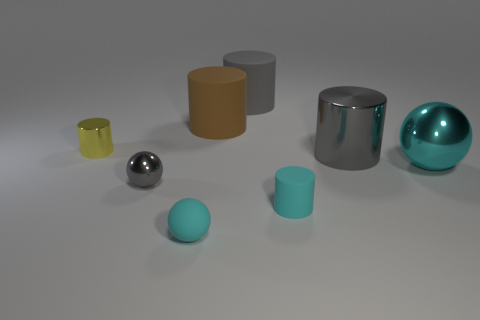Subtract all cyan balls. How many were subtracted if there are1cyan balls left? 1 Subtract all metallic spheres. How many spheres are left? 1 Add 1 big gray matte cylinders. How many objects exist? 9 Subtract all cyan spheres. How many spheres are left? 1 Subtract all cylinders. How many objects are left? 3 Subtract 3 balls. How many balls are left? 0 Add 3 brown matte spheres. How many brown matte spheres exist? 3 Subtract 1 yellow cylinders. How many objects are left? 7 Subtract all brown balls. Subtract all purple cylinders. How many balls are left? 3 Subtract all green cylinders. How many gray spheres are left? 1 